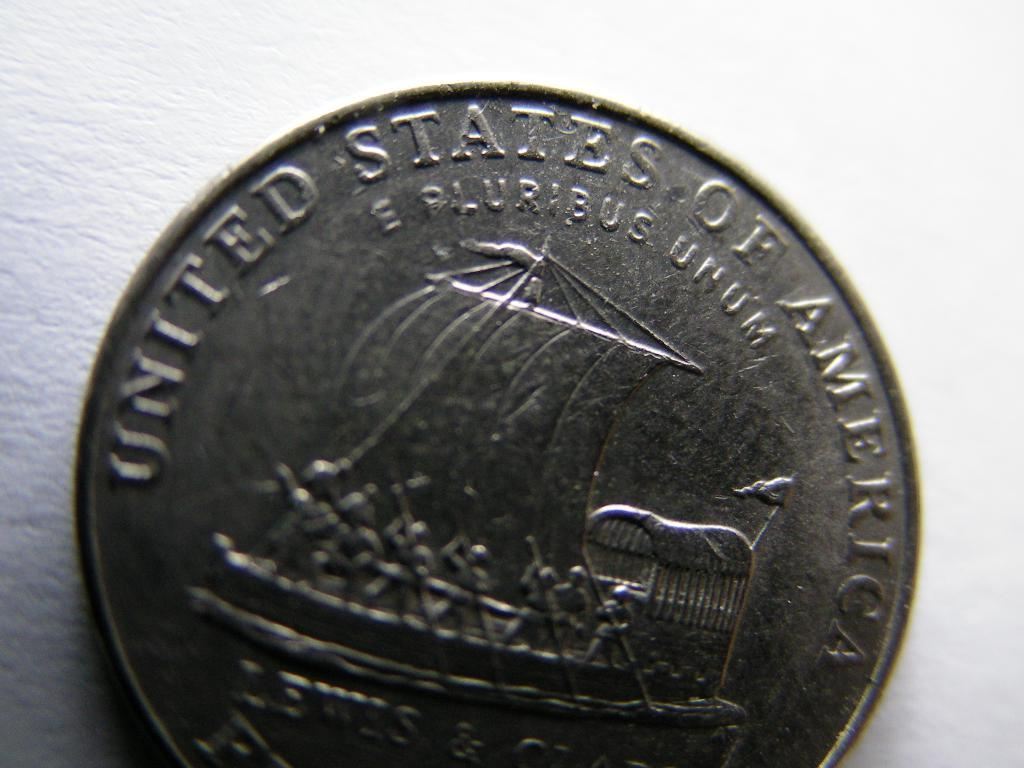<image>
Relay a brief, clear account of the picture shown. A coin reads, "The United States of America" across the top. 